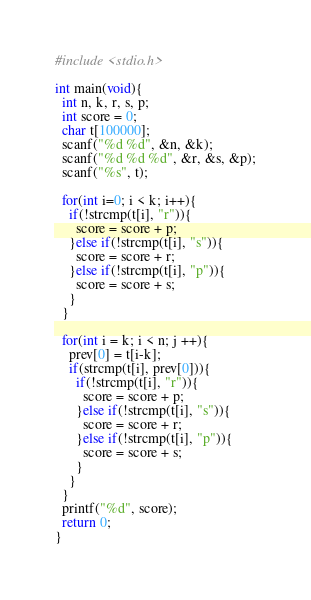Convert code to text. <code><loc_0><loc_0><loc_500><loc_500><_C_>#include <stdio.h>
 
int main(void){
  int n, k, r, s, p;
  int score = 0;
  char t[100000];
  scanf("%d %d", &n, &k);
  scanf("%d %d %d", &r, &s, &p);
  scanf("%s", t);
  
  for(int i=0; i < k; i++){
    if(!strcmp(t[i], "r")){
      score = score + p;
    }else if(!strcmp(t[i], "s")){
      score = score + r;
    }else if(!strcmp(t[i], "p")){
      score = score + s;
    }
  }
  
  for(int i = k; i < n; j ++){
    prev[0] = t[i-k];
    if(strcmp(t[i], prev[0])){
      if(!strcmp(t[i], "r")){
        score = score + p;
      }else if(!strcmp(t[i], "s")){
        score = score + r;
      }else if(!strcmp(t[i], "p")){
        score = score + s;
      }
    }
  }
  printf("%d", score);
  return 0;
}</code> 